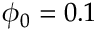<formula> <loc_0><loc_0><loc_500><loc_500>\phi _ { 0 } = 0 . 1</formula> 